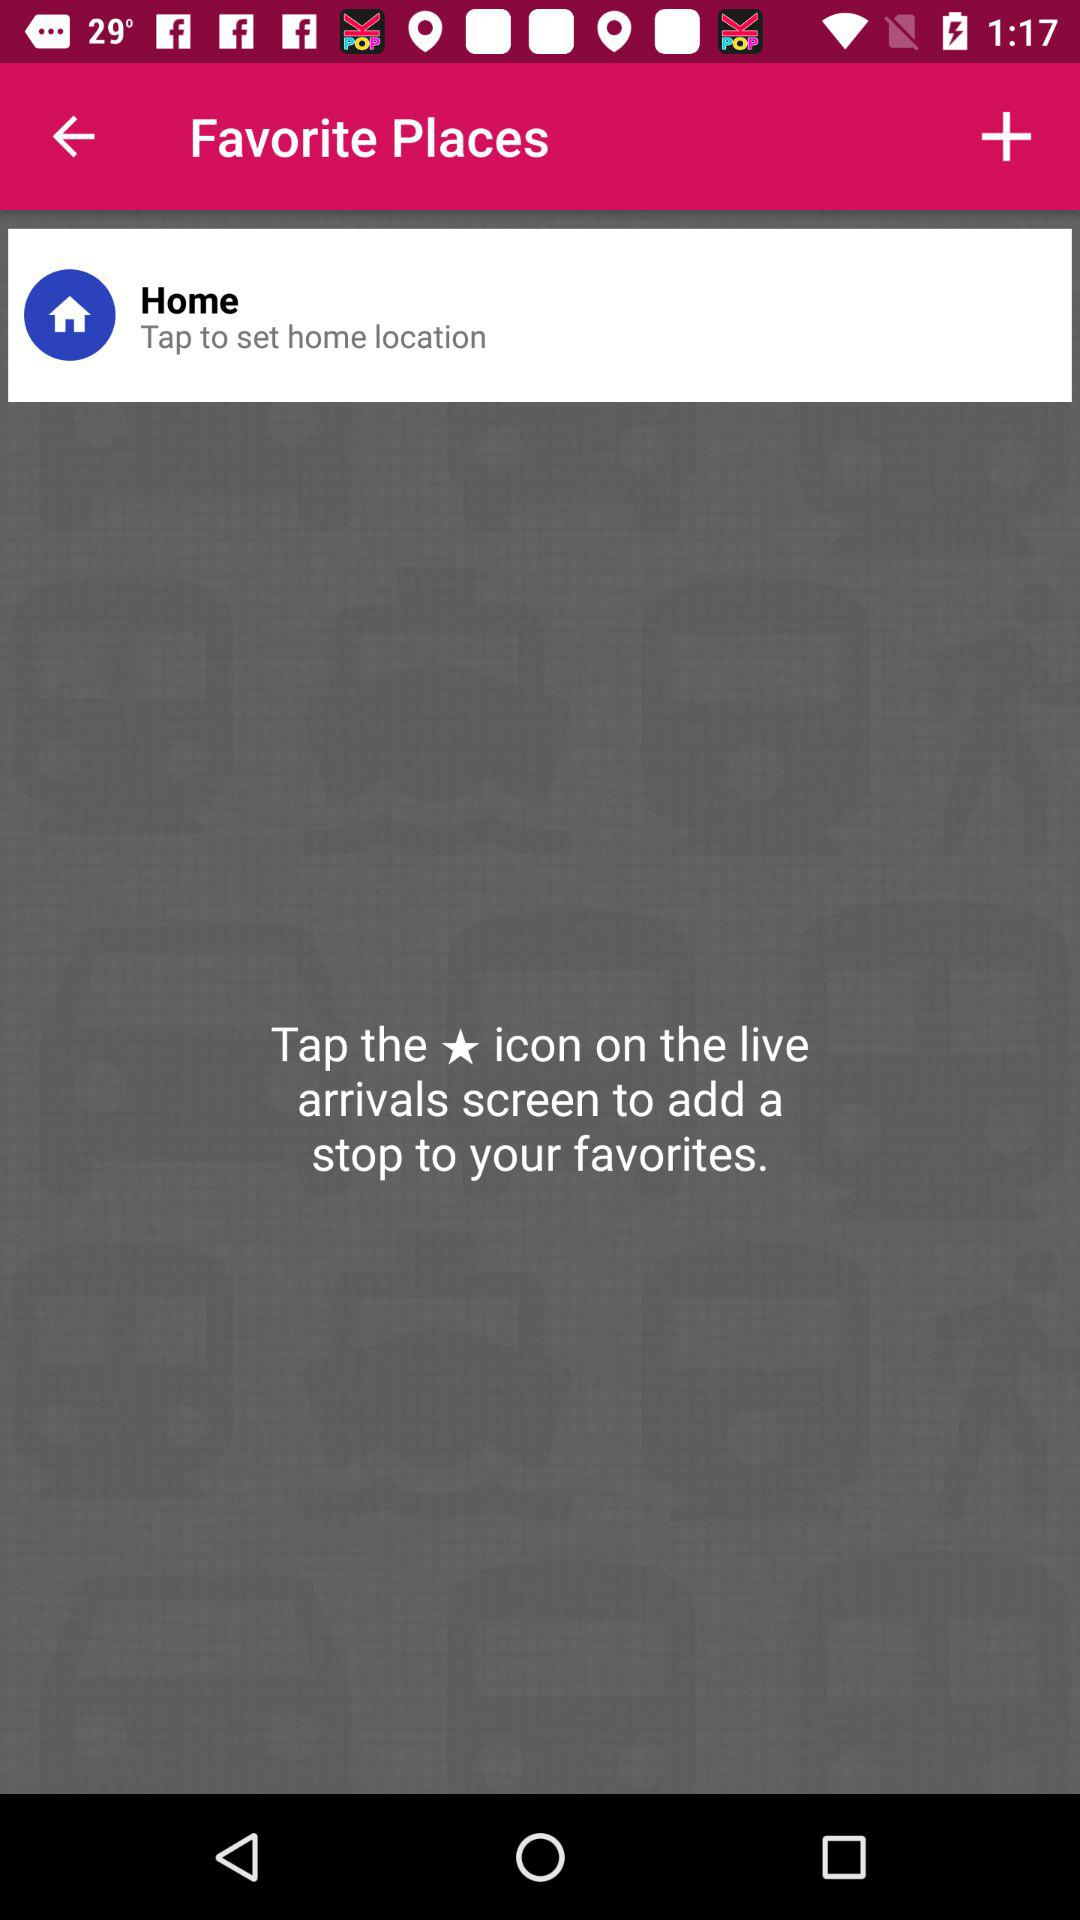What icon is used to add a stop to your favorites? You need to tap on the star icon on the live arrivals screen to add a stop to your favorites. 